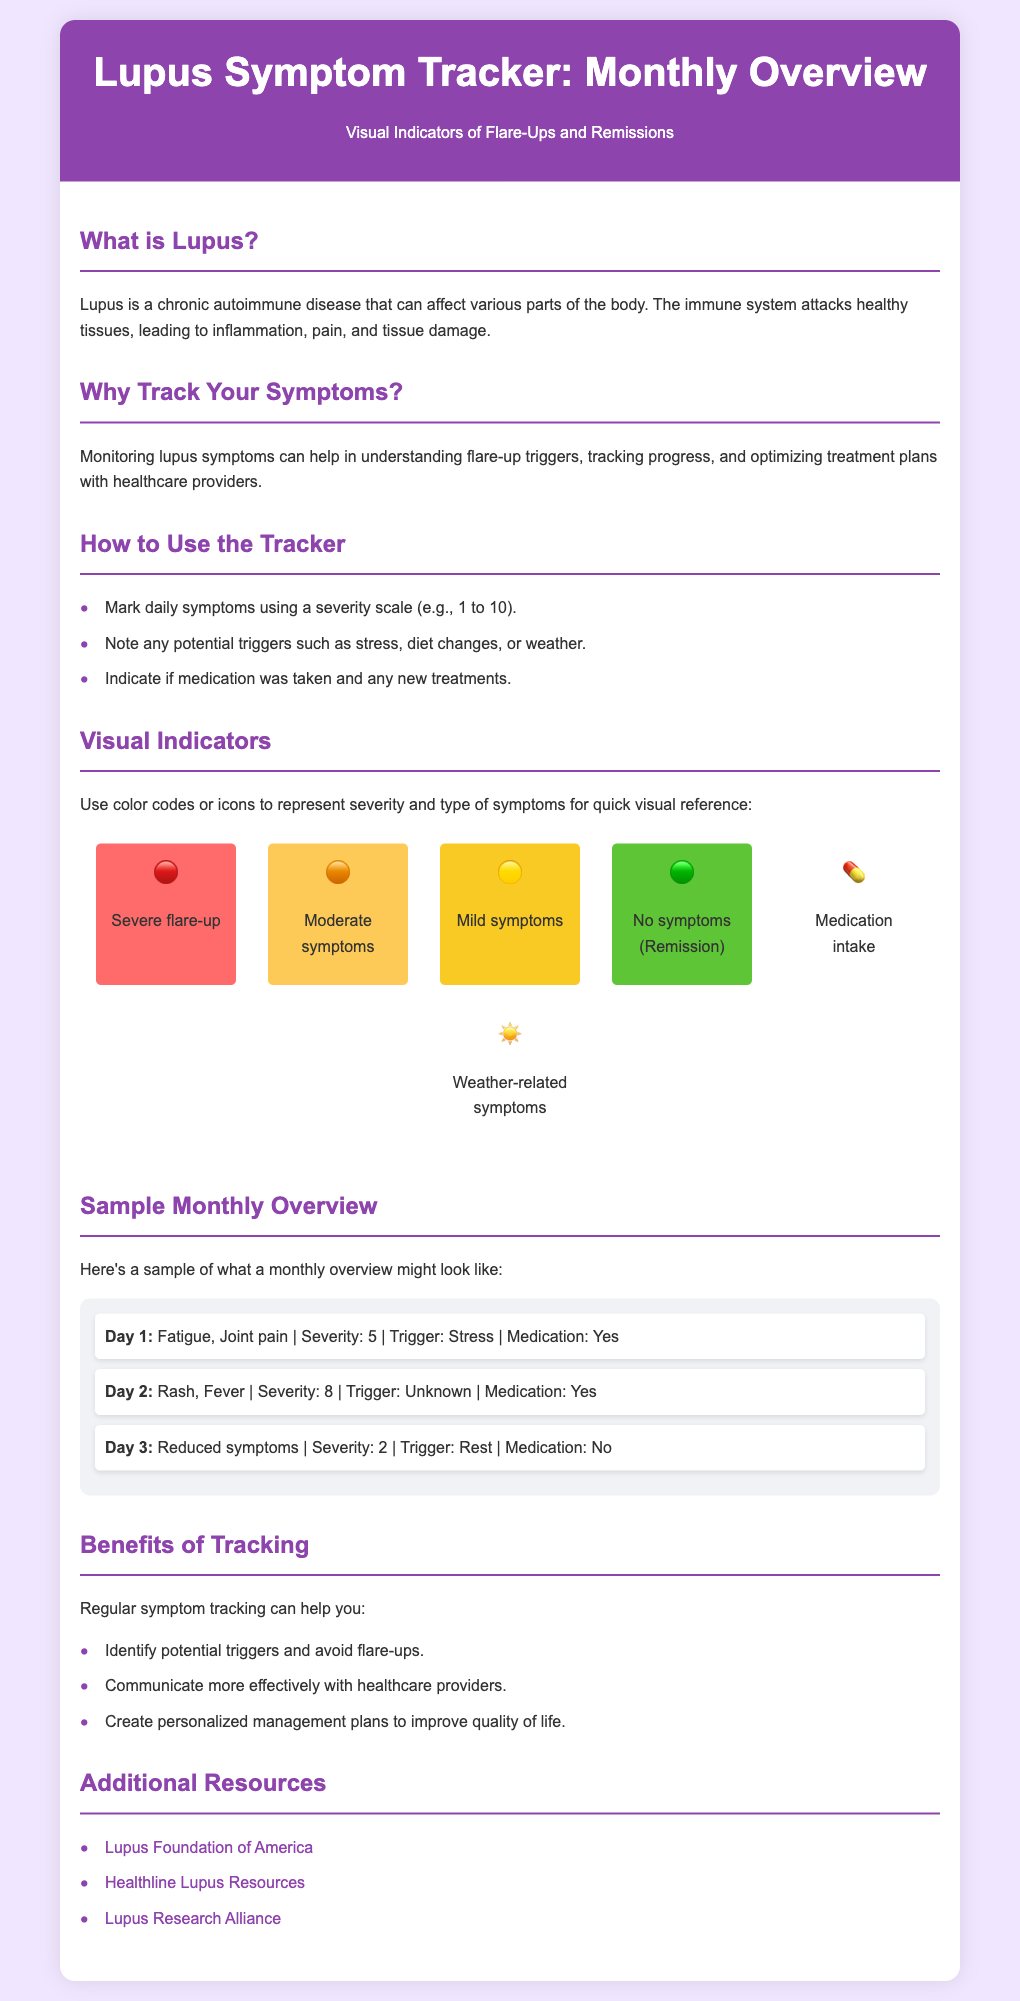What is lupus? The document provides a brief definition of lupus in the "What is Lupus?" section.
Answer: A chronic autoimmune disease Why should one track lupus symptoms? The “Why Track Your Symptoms?” section explains the importance of monitoring symptoms for understanding triggers and treatment.
Answer: To understand flare-up triggers What icon represents severe flare-ups? The visual indicators section includes a specific icon for severe flare-ups, represented in red.
Answer: 🔴 What is the severity level for Day 2 in the sample overview? The sample monthly overview lists severity levels for each day, which is noted for Day 2.
Answer: 8 What are some potential triggers noted in the tracker? The “How to Use the Tracker” section mentions potential triggers that can be noted, including stress, diet changes, and weather.
Answer: Stress What benefit is associated with creating personalized management plans? The “Benefits of Tracking” section discusses creating management plans and improving quality of life related to tracking.
Answer: Improve quality of life What color represents no symptoms (remission)? The visual indicators section includes a specific color for indicating no symptoms, which is green.
Answer: Green Which organization is listed first in the additional resources section? The first resource listed provides an online source for lupus support and information.
Answer: Lupus Foundation of America 